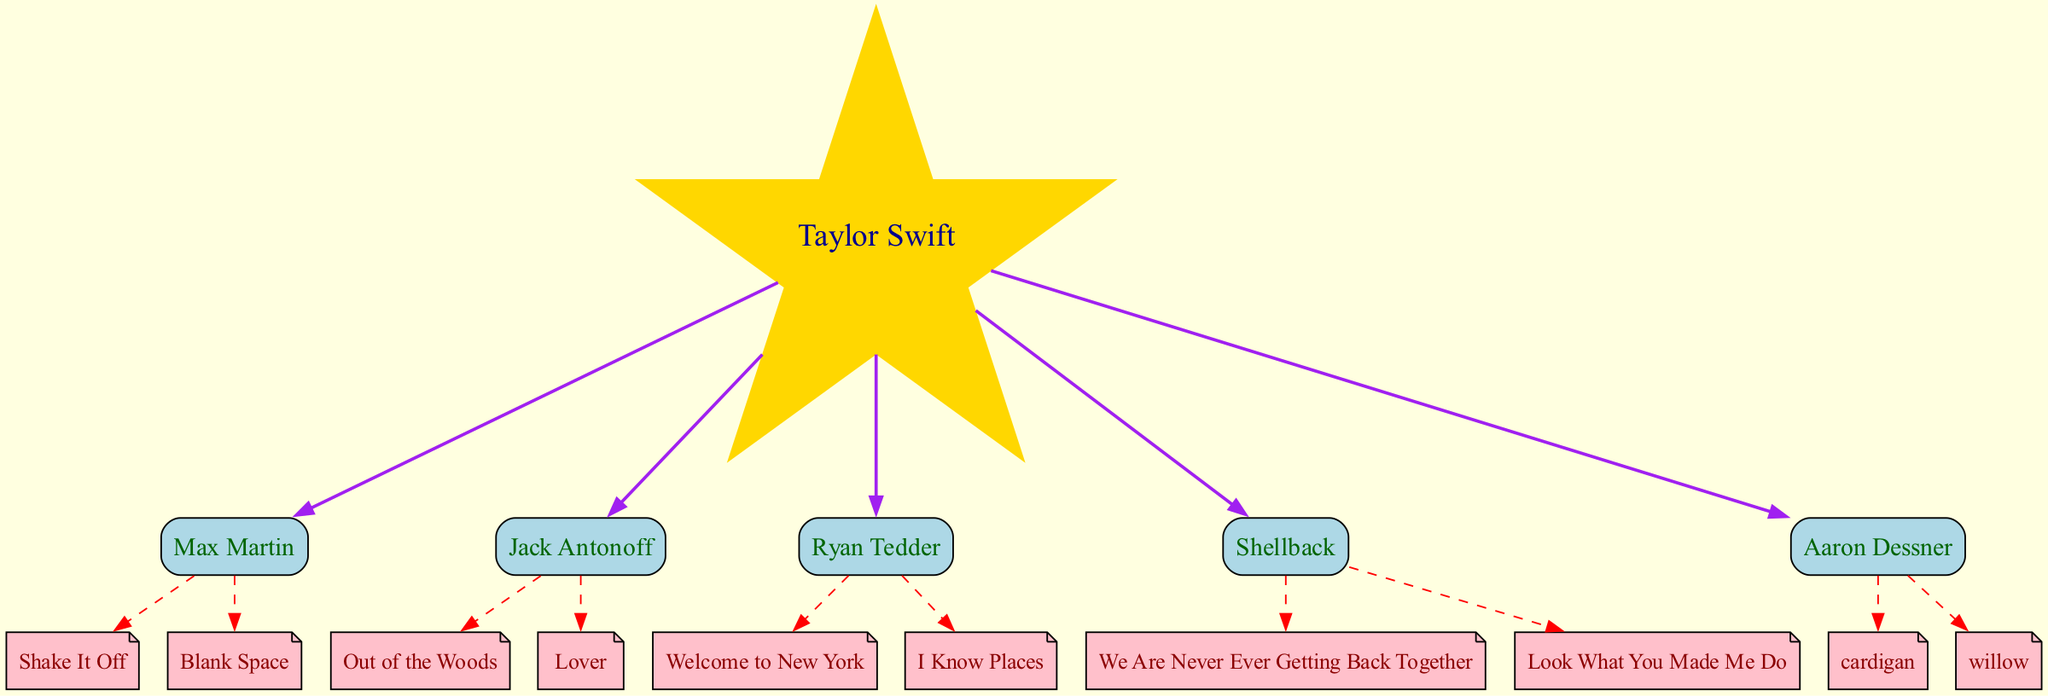What is the root node of this diagram? The root node is Taylor Swift, as indicated at the top of the diagram. It is the primary figure from whom all collaborators and songs branch out in the family tree structure.
Answer: Taylor Swift How many collaborators does Taylor Swift have in this diagram? There are five collaborators listed under Taylor Swift in the diagram, as seen branching out from the root. Counting them gives a total of five names.
Answer: 5 Which collaborator has written "Shake It Off"? The collaborator who has written "Shake It Off" is Max Martin, as indicated by the connection from Taylor Swift to Max Martin, which then leads to the song node "Shake It Off."
Answer: Max Martin What color are the collaborator nodes? The collaborator nodes are colored light blue, as specified in the diagram for all the box-shaped nodes representing collaborators.
Answer: light blue Which song is associated with Aaron Dessner? The songs associated with Aaron Dessner are "cardigan" and "willow." The diagram connects Aaron Dessner to these two song nodes, indicating his collaborations on them.
Answer: cardigan, willow Which collaborator has the most songs listed? Max Martin and Shellback each have two songs listed, while the others are also connected to two songs each. Hence, there isn't a single collaborator with more than two songs; they are all equally distributed in this case.
Answer: Max Martin, Shellback What relationship is depicted between Taylor Swift and her collaborators? The relationship depicted is that of a primary artist (Taylor Swift) with multiple songwriting collaborators, as illustrated by the edges connecting her to each collaborator node in the diagram.
Answer: songwriting partnership Which song connects to Shellback? The songs connected to Shellback are "We Are Never Ever Getting Back Together" and "Look What You Made Me Do," shown in the diagram as direct connections from the collaborator node to the individual song nodes.
Answer: We Are Never Ever Getting Back Together How many total songs are mentioned in the diagram? The total number of songs mentioned can be calculated by counting all individual song nodes connected to their respective collaborator nodes. In this case, there are ten songs in total across all collaborators.
Answer: 10 